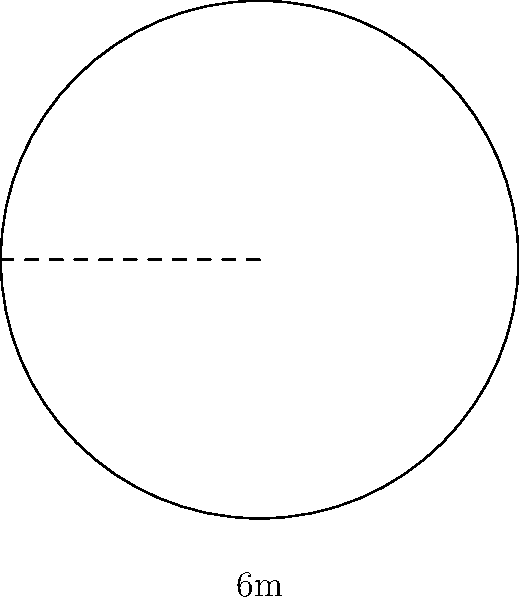A circular meditation platform is being constructed for a new Buddhist retreat center. The diameter of the platform is 6 meters. What is the circumference of the platform, rounded to the nearest tenth of a meter? To find the circumference of the circular meditation platform, we'll follow these steps:

1. Recall the formula for circumference: $C = 2\pi r$, where $r$ is the radius.

2. We're given the diameter, which is 6 meters. The radius is half of the diameter:
   $r = \frac{6}{2} = 3$ meters

3. Now, let's substitute this into our circumference formula:
   $C = 2\pi r = 2\pi(3)$

4. Simplify:
   $C = 6\pi$

5. Calculate the value (using $\pi \approx 3.14159$):
   $C \approx 6 \times 3.14159 = 18.84954$ meters

6. Rounding to the nearest tenth:
   $C \approx 18.8$ meters

Thus, the circumference of the meditation platform is approximately 18.8 meters.
Answer: 18.8 meters 